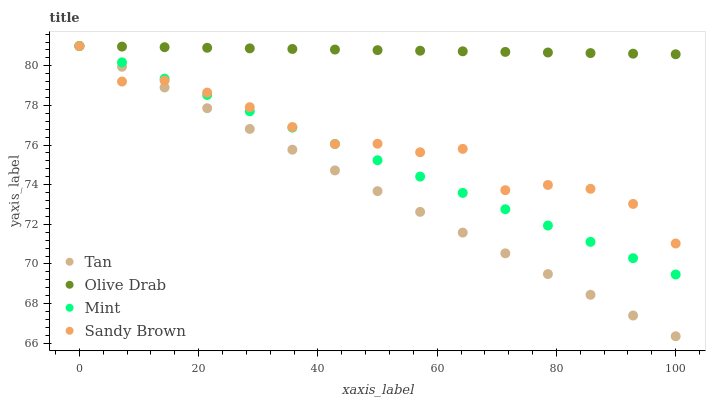Does Tan have the minimum area under the curve?
Answer yes or no. Yes. Does Olive Drab have the maximum area under the curve?
Answer yes or no. Yes. Does Mint have the minimum area under the curve?
Answer yes or no. No. Does Mint have the maximum area under the curve?
Answer yes or no. No. Is Tan the smoothest?
Answer yes or no. Yes. Is Sandy Brown the roughest?
Answer yes or no. Yes. Is Mint the smoothest?
Answer yes or no. No. Is Mint the roughest?
Answer yes or no. No. Does Tan have the lowest value?
Answer yes or no. Yes. Does Mint have the lowest value?
Answer yes or no. No. Does Olive Drab have the highest value?
Answer yes or no. Yes. Does Sandy Brown intersect Tan?
Answer yes or no. Yes. Is Sandy Brown less than Tan?
Answer yes or no. No. Is Sandy Brown greater than Tan?
Answer yes or no. No. 